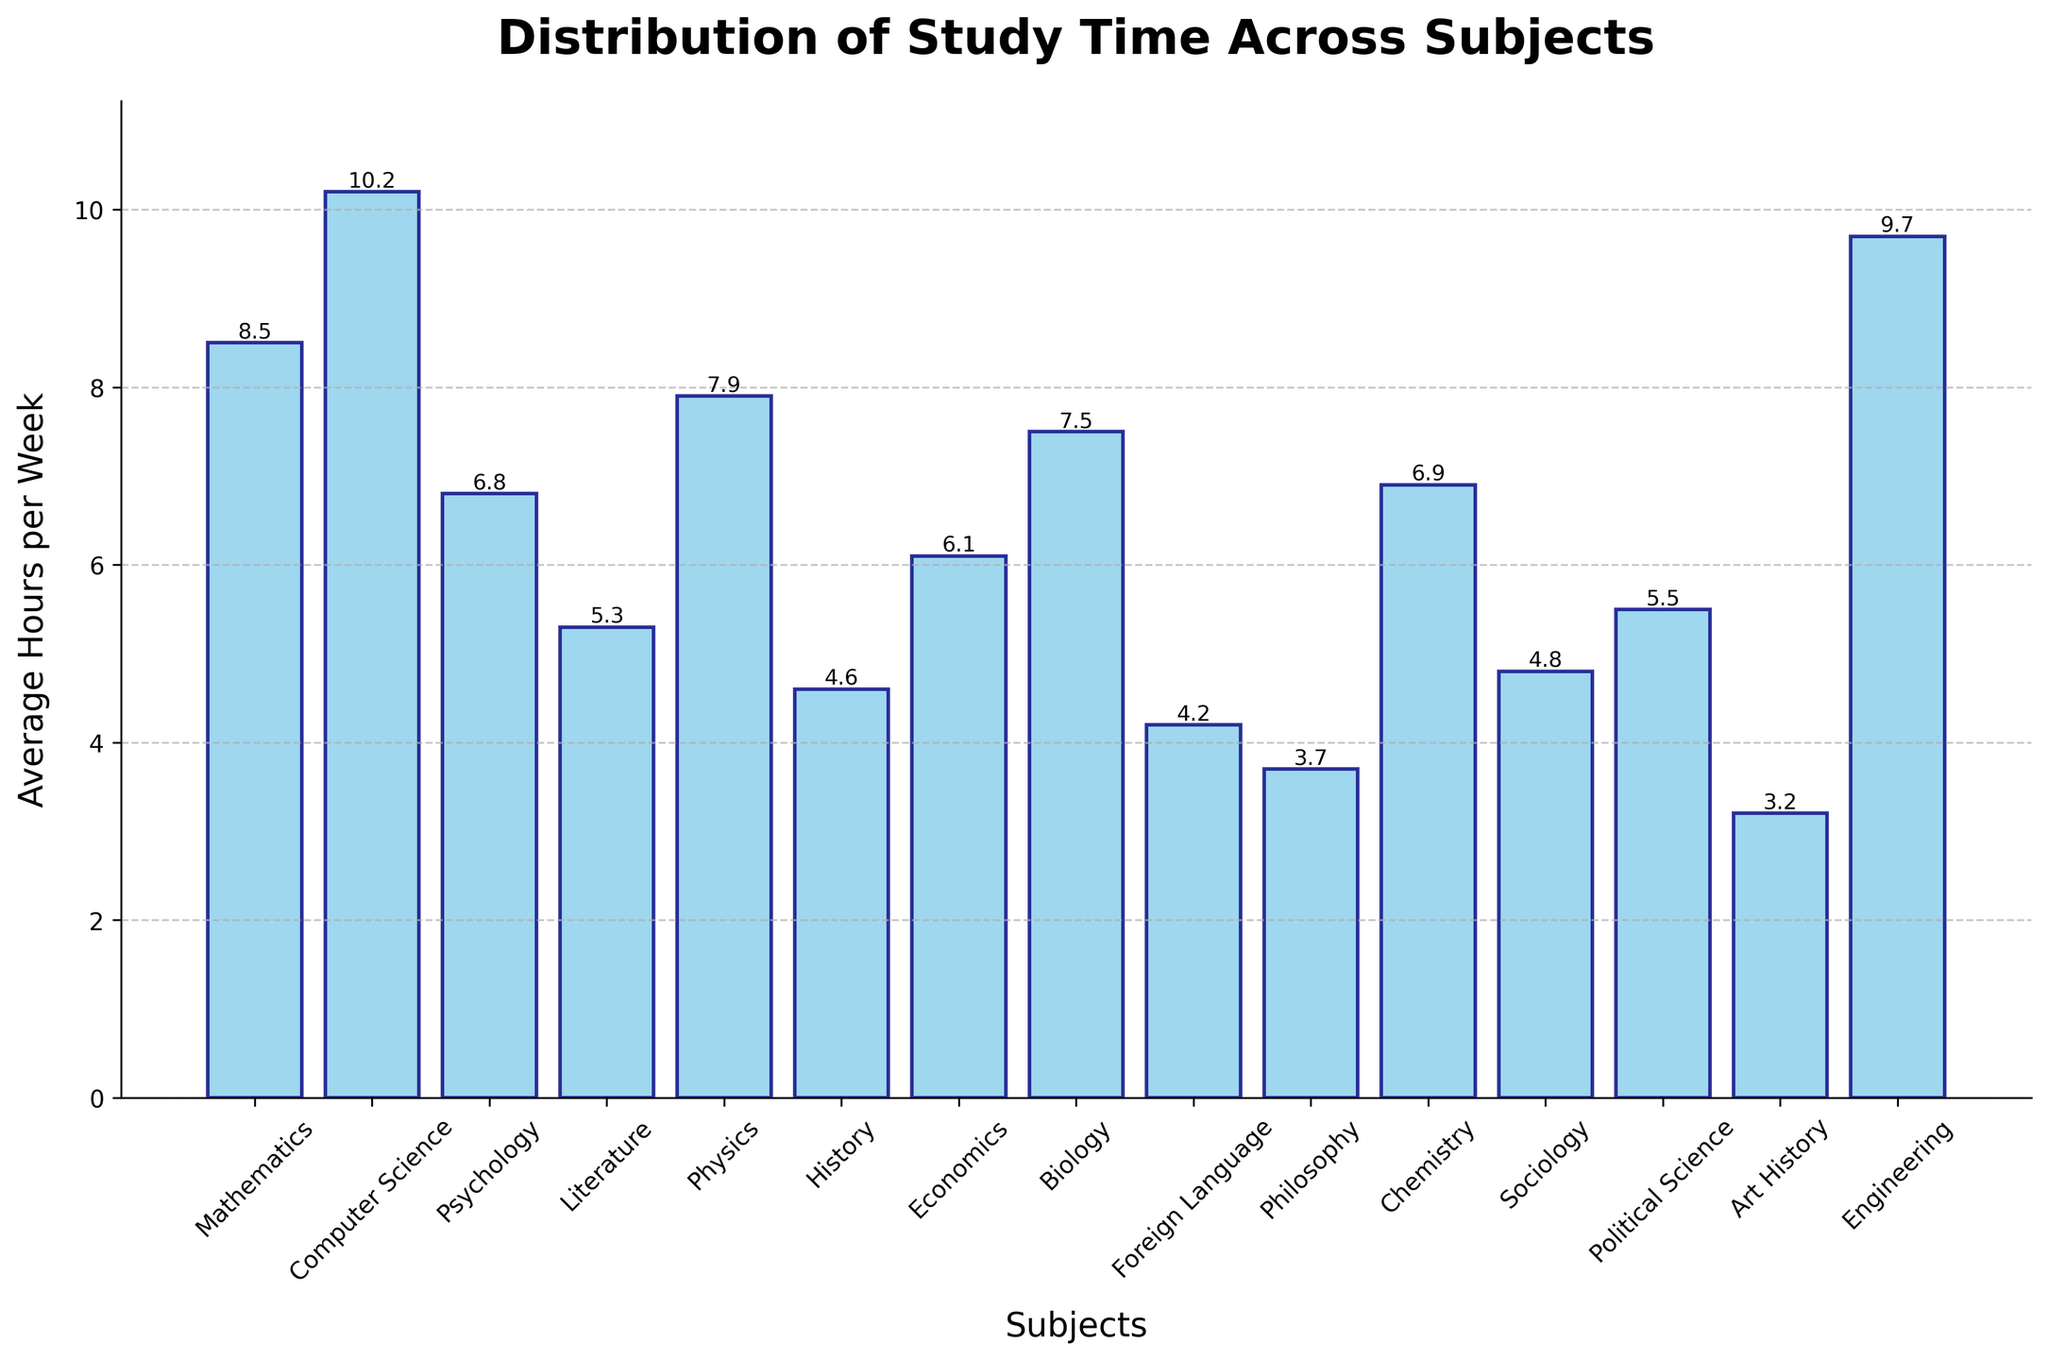Which subject do students spend the most average hours per week studying? The bar with the greatest height represents the subject with the most average hours per week. In this case, it is Computer Science with 10.2 hours per week.
Answer: Computer Science Which subject do students spend the least average hours per week studying? The bar with the smallest height represents the subject with the least average hours per week. In this case, it is Art History with 3.2 hours per week.
Answer: Art History How much more time do students spend on average studying Computer Science compared to Foreign Language? Subtract the average hours per week for Foreign Language from the average hours per week for Computer Science (10.2 - 4.2).
Answer: 6 hours What is the total average study time per week for Mathematics, Physics, and Chemistry combined? Add the average hours per week for Mathematics, Physics, and Chemistry (8.5 + 7.9 + 6.9).
Answer: 23.3 hours Which subjects do students, on average, spend more than 7 hours a week studying? Identify the bars with heights greater than 7. These subjects are Mathematics, Computer Science, Physics, Biology, and Engineering.
Answer: Mathematics, Computer Science, Physics, Biology, Engineering How many subjects do students spend less than 5 hours per week on average studying? Count the bars with heights less than 5. These subjects are History, Foreign Language, Philosophy, and Art History.
Answer: 4 subjects What is the average study time across all subjects? Sum all the average hours per week and divide by the number of subjects. First, calculate the sum (8.5 + 10.2 + 6.8 + 5.3 + 7.9 + 4.6 + 6.1 + 7.5 + 4.2 + 3.7 + 6.9 + 4.8 + 5.5 + 3.2 + 9.7) = 94.9, then divide by the number of subjects (15).
Answer: 6.3 hours per week Which two subjects have the closest average study time, and what is the difference between them? Look at the average hours per week and identify the smallest difference. Chemistry (6.9) and Psychology (6.8) have the closest study times. The difference is (6.9 - 6.8).
Answer: Chemistry and Psychology, 0.1 hours How does the average study time for Engineering compare to that for Physics? Compare the heights of the bars for Engineering and Physics. Engineering is 9.7 hours per week, and Physics is 7.9 hours per week.
Answer: Engineering is more by 1.8 hours 